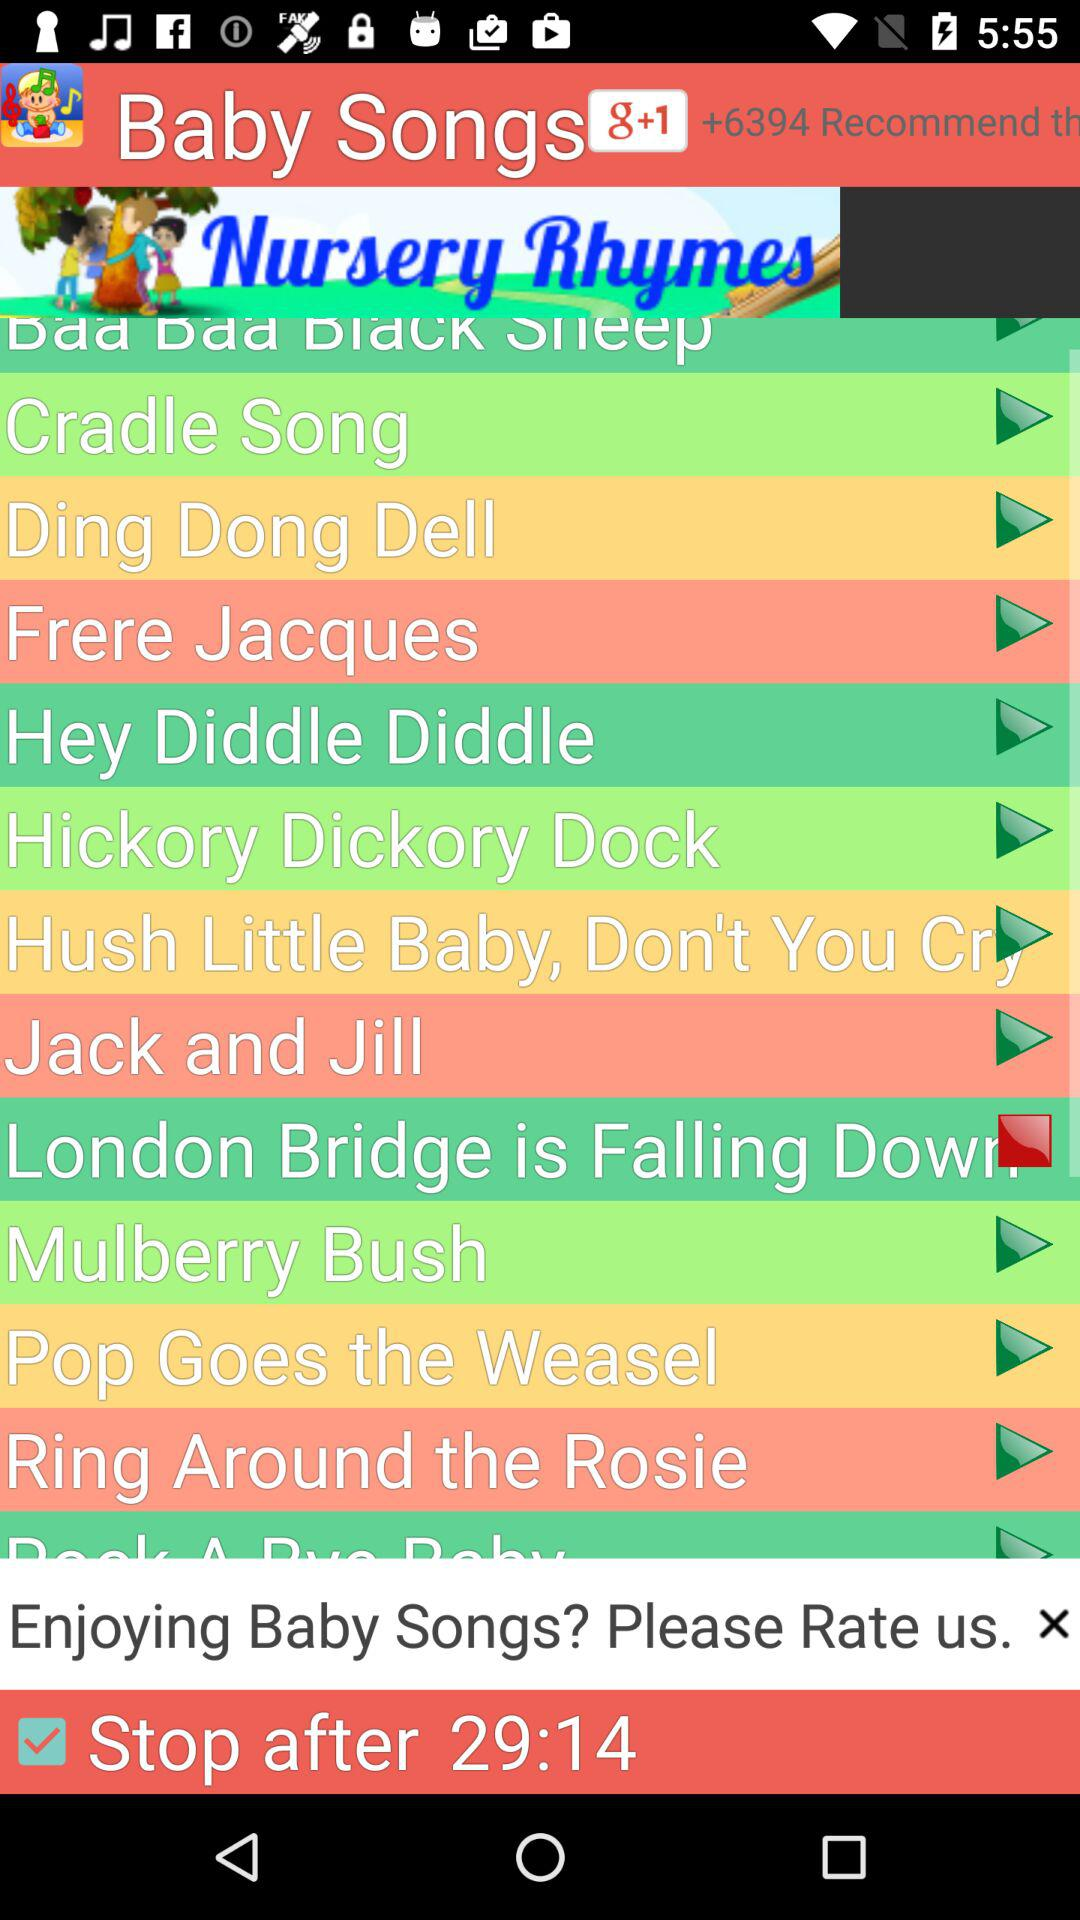How many people recommended the application? The application was recommended by +6394 people. 